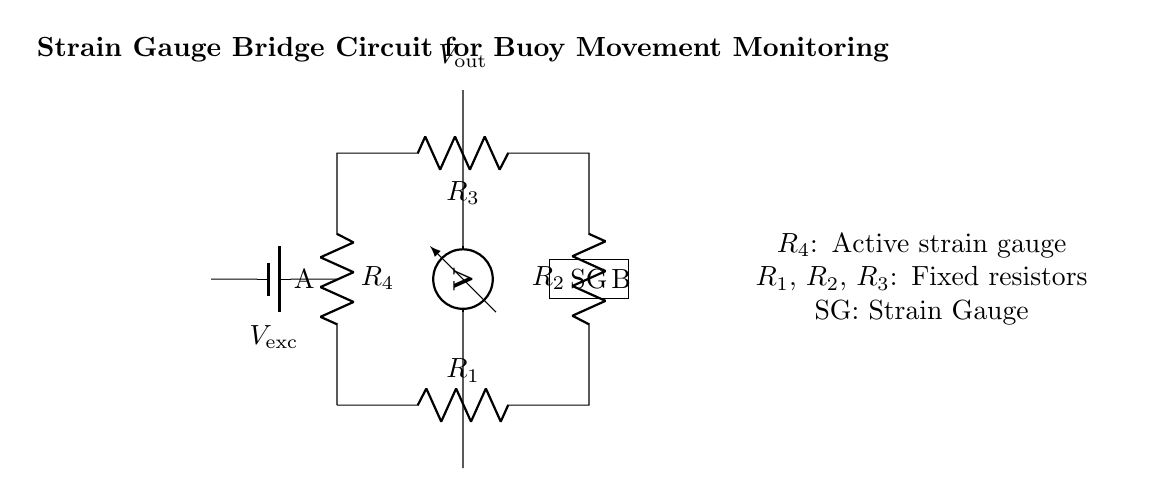What type of circuit is shown? The circuit is a strain gauge bridge circuit designed for monitoring changes in resistance due to buoy movement. This is indicated by the arrangement of the resistors and the specific mention of a strain gauge.
Answer: strain gauge bridge What is the purpose of the voltmeter? The voltmeter is used to measure the output voltage across the points of the bridge, which indicates the difference in resistance caused by the strain gauge’s response to movement. This is evident from its placement and label in the diagram.
Answer: measure output voltage What component acts as the active strain gauge? The strain gauge is represented by the labeled block 'SG' in the diagram, indicating its function in detecting strain or deformation.
Answer: SG How many resistors are in the bridge? There are four resistors labeled as R1, R2, R3, and R4; this can be counted directly from the diagram.
Answer: four What is the role of R4? R4 is the active strain gauge in the circuit, responding to deformation. Its role can be identified from the accompanying label and description in the diagram.
Answer: active strain gauge What does the voltage source provide? The voltage source provides the excitation voltage needed to enable the measurement of changes in resistance and resultant output voltage. Its presence and label confirm its function in the circuit.
Answer: excitation voltage 